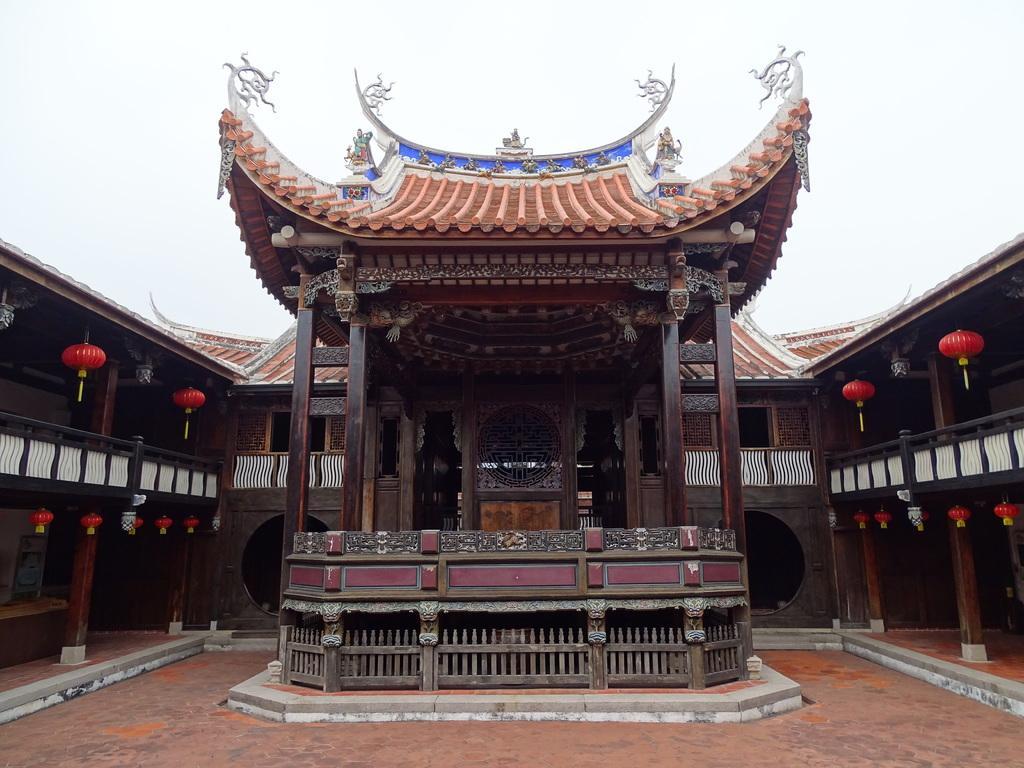Describe this image in one or two sentences. In this image, we can see some houses and wooden pillars. We can see the ground and some red colored objects. We can also see the sky. 